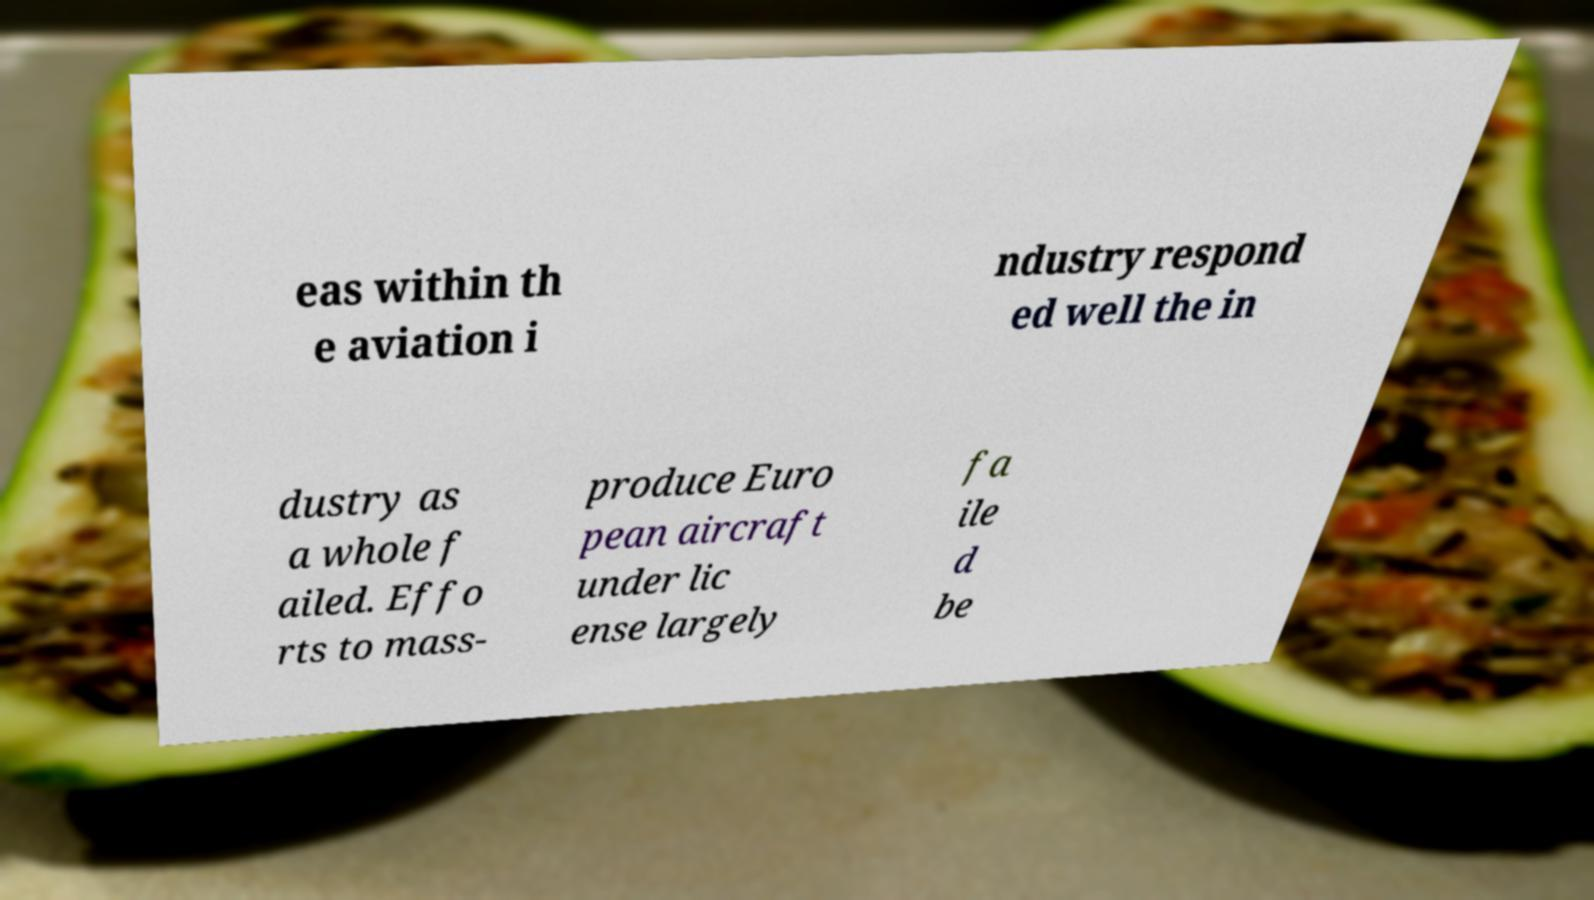Can you accurately transcribe the text from the provided image for me? eas within th e aviation i ndustry respond ed well the in dustry as a whole f ailed. Effo rts to mass- produce Euro pean aircraft under lic ense largely fa ile d be 